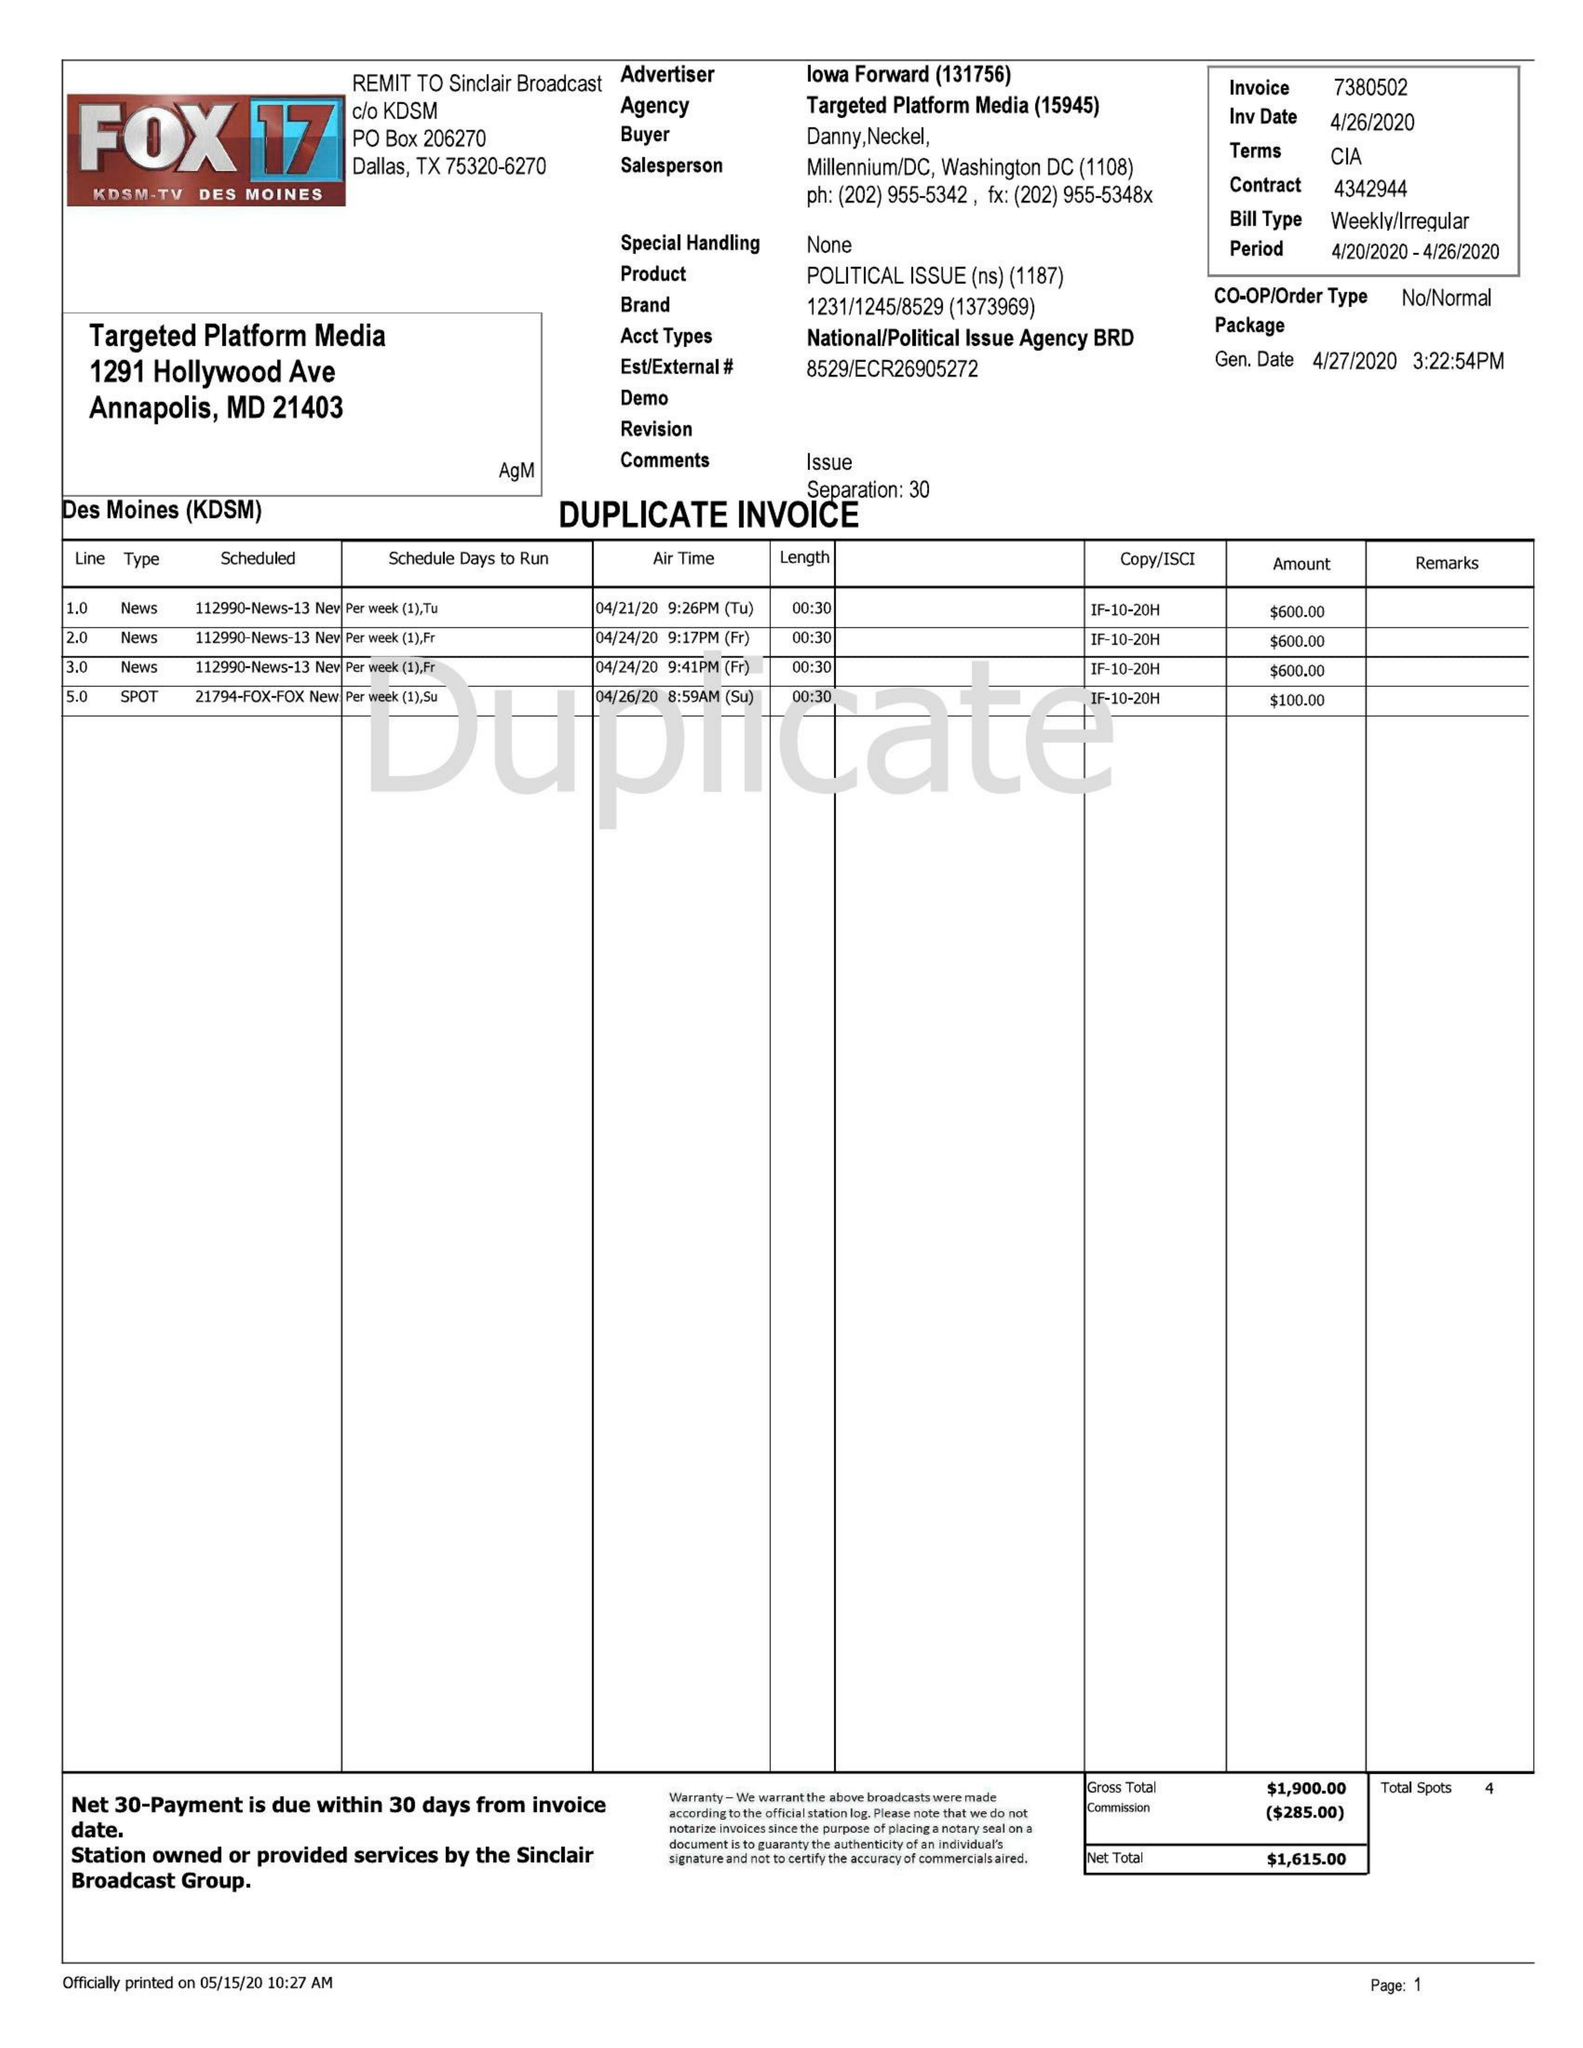What is the value for the flight_from?
Answer the question using a single word or phrase. 04/20/20 